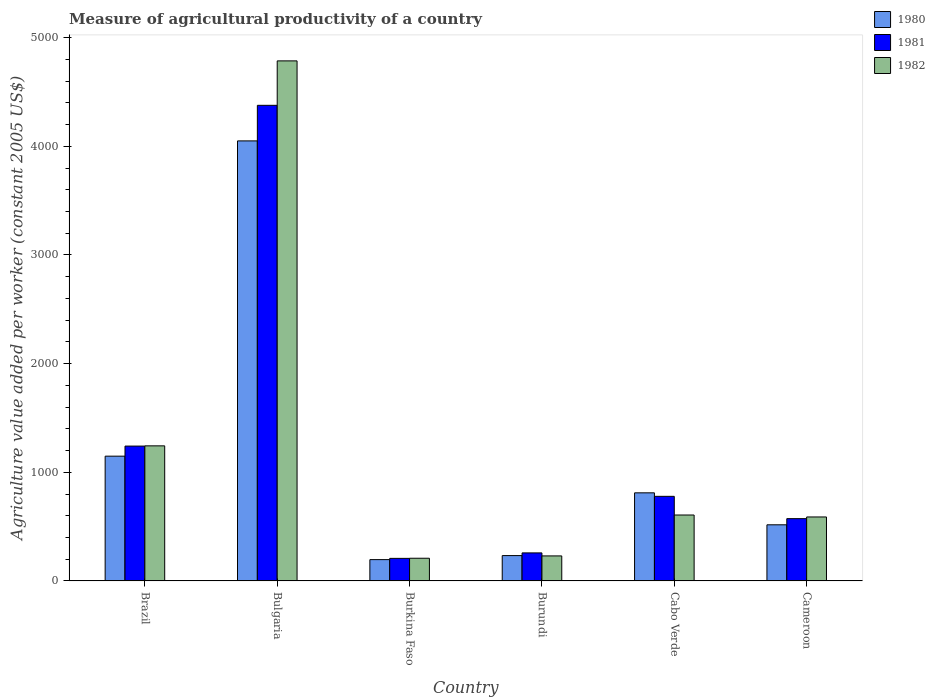How many different coloured bars are there?
Offer a very short reply. 3. How many groups of bars are there?
Provide a succinct answer. 6. Are the number of bars per tick equal to the number of legend labels?
Provide a short and direct response. Yes. Are the number of bars on each tick of the X-axis equal?
Offer a very short reply. Yes. How many bars are there on the 5th tick from the left?
Provide a short and direct response. 3. What is the label of the 1st group of bars from the left?
Ensure brevity in your answer.  Brazil. In how many cases, is the number of bars for a given country not equal to the number of legend labels?
Your answer should be compact. 0. What is the measure of agricultural productivity in 1980 in Brazil?
Offer a very short reply. 1148.46. Across all countries, what is the maximum measure of agricultural productivity in 1981?
Give a very brief answer. 4377.54. Across all countries, what is the minimum measure of agricultural productivity in 1982?
Your answer should be compact. 208.91. In which country was the measure of agricultural productivity in 1981 minimum?
Your response must be concise. Burkina Faso. What is the total measure of agricultural productivity in 1980 in the graph?
Give a very brief answer. 6955.51. What is the difference between the measure of agricultural productivity in 1980 in Bulgaria and that in Burkina Faso?
Provide a short and direct response. 3853.72. What is the difference between the measure of agricultural productivity in 1981 in Burundi and the measure of agricultural productivity in 1982 in Cabo Verde?
Make the answer very short. -348.66. What is the average measure of agricultural productivity in 1980 per country?
Ensure brevity in your answer.  1159.25. What is the difference between the measure of agricultural productivity of/in 1980 and measure of agricultural productivity of/in 1981 in Burundi?
Your response must be concise. -24.79. What is the ratio of the measure of agricultural productivity in 1980 in Bulgaria to that in Cameroon?
Provide a short and direct response. 7.84. Is the measure of agricultural productivity in 1980 in Brazil less than that in Cabo Verde?
Your answer should be compact. No. What is the difference between the highest and the second highest measure of agricultural productivity in 1980?
Provide a short and direct response. 3239.07. What is the difference between the highest and the lowest measure of agricultural productivity in 1981?
Give a very brief answer. 4169.76. Is the sum of the measure of agricultural productivity in 1980 in Brazil and Cabo Verde greater than the maximum measure of agricultural productivity in 1982 across all countries?
Ensure brevity in your answer.  No. What does the 1st bar from the left in Cameroon represents?
Your answer should be very brief. 1980. Is it the case that in every country, the sum of the measure of agricultural productivity in 1982 and measure of agricultural productivity in 1980 is greater than the measure of agricultural productivity in 1981?
Provide a succinct answer. Yes. What is the difference between two consecutive major ticks on the Y-axis?
Make the answer very short. 1000. Does the graph contain any zero values?
Your answer should be very brief. No. Where does the legend appear in the graph?
Offer a very short reply. Top right. How many legend labels are there?
Your answer should be compact. 3. How are the legend labels stacked?
Make the answer very short. Vertical. What is the title of the graph?
Ensure brevity in your answer.  Measure of agricultural productivity of a country. Does "1987" appear as one of the legend labels in the graph?
Provide a succinct answer. No. What is the label or title of the X-axis?
Make the answer very short. Country. What is the label or title of the Y-axis?
Offer a very short reply. Agriculture value added per worker (constant 2005 US$). What is the Agriculture value added per worker (constant 2005 US$) of 1980 in Brazil?
Provide a succinct answer. 1148.46. What is the Agriculture value added per worker (constant 2005 US$) in 1981 in Brazil?
Your response must be concise. 1241.2. What is the Agriculture value added per worker (constant 2005 US$) of 1982 in Brazil?
Offer a very short reply. 1243.26. What is the Agriculture value added per worker (constant 2005 US$) of 1980 in Bulgaria?
Give a very brief answer. 4049.97. What is the Agriculture value added per worker (constant 2005 US$) of 1981 in Bulgaria?
Your answer should be compact. 4377.54. What is the Agriculture value added per worker (constant 2005 US$) of 1982 in Bulgaria?
Provide a short and direct response. 4786.52. What is the Agriculture value added per worker (constant 2005 US$) of 1980 in Burkina Faso?
Make the answer very short. 196.25. What is the Agriculture value added per worker (constant 2005 US$) in 1981 in Burkina Faso?
Offer a terse response. 207.78. What is the Agriculture value added per worker (constant 2005 US$) in 1982 in Burkina Faso?
Keep it short and to the point. 208.91. What is the Agriculture value added per worker (constant 2005 US$) of 1980 in Burundi?
Offer a terse response. 233.32. What is the Agriculture value added per worker (constant 2005 US$) in 1981 in Burundi?
Ensure brevity in your answer.  258.11. What is the Agriculture value added per worker (constant 2005 US$) in 1982 in Burundi?
Make the answer very short. 230.29. What is the Agriculture value added per worker (constant 2005 US$) in 1980 in Cabo Verde?
Your response must be concise. 810.9. What is the Agriculture value added per worker (constant 2005 US$) in 1981 in Cabo Verde?
Give a very brief answer. 778.63. What is the Agriculture value added per worker (constant 2005 US$) in 1982 in Cabo Verde?
Your response must be concise. 606.77. What is the Agriculture value added per worker (constant 2005 US$) of 1980 in Cameroon?
Make the answer very short. 516.62. What is the Agriculture value added per worker (constant 2005 US$) in 1981 in Cameroon?
Keep it short and to the point. 573.32. What is the Agriculture value added per worker (constant 2005 US$) of 1982 in Cameroon?
Your answer should be compact. 588.87. Across all countries, what is the maximum Agriculture value added per worker (constant 2005 US$) in 1980?
Your answer should be compact. 4049.97. Across all countries, what is the maximum Agriculture value added per worker (constant 2005 US$) of 1981?
Give a very brief answer. 4377.54. Across all countries, what is the maximum Agriculture value added per worker (constant 2005 US$) of 1982?
Provide a short and direct response. 4786.52. Across all countries, what is the minimum Agriculture value added per worker (constant 2005 US$) of 1980?
Give a very brief answer. 196.25. Across all countries, what is the minimum Agriculture value added per worker (constant 2005 US$) in 1981?
Offer a terse response. 207.78. Across all countries, what is the minimum Agriculture value added per worker (constant 2005 US$) of 1982?
Offer a very short reply. 208.91. What is the total Agriculture value added per worker (constant 2005 US$) in 1980 in the graph?
Offer a very short reply. 6955.51. What is the total Agriculture value added per worker (constant 2005 US$) of 1981 in the graph?
Make the answer very short. 7436.59. What is the total Agriculture value added per worker (constant 2005 US$) in 1982 in the graph?
Offer a very short reply. 7664.62. What is the difference between the Agriculture value added per worker (constant 2005 US$) of 1980 in Brazil and that in Bulgaria?
Offer a very short reply. -2901.51. What is the difference between the Agriculture value added per worker (constant 2005 US$) of 1981 in Brazil and that in Bulgaria?
Offer a terse response. -3136.34. What is the difference between the Agriculture value added per worker (constant 2005 US$) in 1982 in Brazil and that in Bulgaria?
Offer a very short reply. -3543.26. What is the difference between the Agriculture value added per worker (constant 2005 US$) in 1980 in Brazil and that in Burkina Faso?
Make the answer very short. 952.21. What is the difference between the Agriculture value added per worker (constant 2005 US$) in 1981 in Brazil and that in Burkina Faso?
Provide a short and direct response. 1033.42. What is the difference between the Agriculture value added per worker (constant 2005 US$) in 1982 in Brazil and that in Burkina Faso?
Give a very brief answer. 1034.35. What is the difference between the Agriculture value added per worker (constant 2005 US$) in 1980 in Brazil and that in Burundi?
Give a very brief answer. 915.13. What is the difference between the Agriculture value added per worker (constant 2005 US$) of 1981 in Brazil and that in Burundi?
Provide a succinct answer. 983.09. What is the difference between the Agriculture value added per worker (constant 2005 US$) of 1982 in Brazil and that in Burundi?
Offer a very short reply. 1012.97. What is the difference between the Agriculture value added per worker (constant 2005 US$) in 1980 in Brazil and that in Cabo Verde?
Make the answer very short. 337.56. What is the difference between the Agriculture value added per worker (constant 2005 US$) in 1981 in Brazil and that in Cabo Verde?
Your answer should be very brief. 462.57. What is the difference between the Agriculture value added per worker (constant 2005 US$) in 1982 in Brazil and that in Cabo Verde?
Make the answer very short. 636.49. What is the difference between the Agriculture value added per worker (constant 2005 US$) in 1980 in Brazil and that in Cameroon?
Offer a terse response. 631.84. What is the difference between the Agriculture value added per worker (constant 2005 US$) in 1981 in Brazil and that in Cameroon?
Your answer should be compact. 667.88. What is the difference between the Agriculture value added per worker (constant 2005 US$) of 1982 in Brazil and that in Cameroon?
Your response must be concise. 654.39. What is the difference between the Agriculture value added per worker (constant 2005 US$) of 1980 in Bulgaria and that in Burkina Faso?
Ensure brevity in your answer.  3853.72. What is the difference between the Agriculture value added per worker (constant 2005 US$) of 1981 in Bulgaria and that in Burkina Faso?
Your answer should be very brief. 4169.76. What is the difference between the Agriculture value added per worker (constant 2005 US$) in 1982 in Bulgaria and that in Burkina Faso?
Your answer should be very brief. 4577.61. What is the difference between the Agriculture value added per worker (constant 2005 US$) in 1980 in Bulgaria and that in Burundi?
Offer a terse response. 3816.65. What is the difference between the Agriculture value added per worker (constant 2005 US$) in 1981 in Bulgaria and that in Burundi?
Provide a succinct answer. 4119.43. What is the difference between the Agriculture value added per worker (constant 2005 US$) of 1982 in Bulgaria and that in Burundi?
Make the answer very short. 4556.24. What is the difference between the Agriculture value added per worker (constant 2005 US$) in 1980 in Bulgaria and that in Cabo Verde?
Keep it short and to the point. 3239.07. What is the difference between the Agriculture value added per worker (constant 2005 US$) in 1981 in Bulgaria and that in Cabo Verde?
Keep it short and to the point. 3598.91. What is the difference between the Agriculture value added per worker (constant 2005 US$) of 1982 in Bulgaria and that in Cabo Verde?
Offer a terse response. 4179.75. What is the difference between the Agriculture value added per worker (constant 2005 US$) in 1980 in Bulgaria and that in Cameroon?
Your response must be concise. 3533.35. What is the difference between the Agriculture value added per worker (constant 2005 US$) of 1981 in Bulgaria and that in Cameroon?
Offer a terse response. 3804.22. What is the difference between the Agriculture value added per worker (constant 2005 US$) of 1982 in Bulgaria and that in Cameroon?
Provide a short and direct response. 4197.65. What is the difference between the Agriculture value added per worker (constant 2005 US$) in 1980 in Burkina Faso and that in Burundi?
Give a very brief answer. -37.08. What is the difference between the Agriculture value added per worker (constant 2005 US$) of 1981 in Burkina Faso and that in Burundi?
Provide a succinct answer. -50.33. What is the difference between the Agriculture value added per worker (constant 2005 US$) of 1982 in Burkina Faso and that in Burundi?
Your response must be concise. -21.37. What is the difference between the Agriculture value added per worker (constant 2005 US$) in 1980 in Burkina Faso and that in Cabo Verde?
Keep it short and to the point. -614.65. What is the difference between the Agriculture value added per worker (constant 2005 US$) in 1981 in Burkina Faso and that in Cabo Verde?
Your answer should be compact. -570.85. What is the difference between the Agriculture value added per worker (constant 2005 US$) of 1982 in Burkina Faso and that in Cabo Verde?
Provide a succinct answer. -397.86. What is the difference between the Agriculture value added per worker (constant 2005 US$) of 1980 in Burkina Faso and that in Cameroon?
Provide a short and direct response. -320.37. What is the difference between the Agriculture value added per worker (constant 2005 US$) in 1981 in Burkina Faso and that in Cameroon?
Keep it short and to the point. -365.54. What is the difference between the Agriculture value added per worker (constant 2005 US$) in 1982 in Burkina Faso and that in Cameroon?
Give a very brief answer. -379.96. What is the difference between the Agriculture value added per worker (constant 2005 US$) in 1980 in Burundi and that in Cabo Verde?
Your answer should be very brief. -577.57. What is the difference between the Agriculture value added per worker (constant 2005 US$) of 1981 in Burundi and that in Cabo Verde?
Your answer should be very brief. -520.52. What is the difference between the Agriculture value added per worker (constant 2005 US$) in 1982 in Burundi and that in Cabo Verde?
Provide a short and direct response. -376.49. What is the difference between the Agriculture value added per worker (constant 2005 US$) of 1980 in Burundi and that in Cameroon?
Your response must be concise. -283.29. What is the difference between the Agriculture value added per worker (constant 2005 US$) in 1981 in Burundi and that in Cameroon?
Keep it short and to the point. -315.21. What is the difference between the Agriculture value added per worker (constant 2005 US$) of 1982 in Burundi and that in Cameroon?
Offer a very short reply. -358.59. What is the difference between the Agriculture value added per worker (constant 2005 US$) in 1980 in Cabo Verde and that in Cameroon?
Keep it short and to the point. 294.28. What is the difference between the Agriculture value added per worker (constant 2005 US$) of 1981 in Cabo Verde and that in Cameroon?
Your answer should be very brief. 205.31. What is the difference between the Agriculture value added per worker (constant 2005 US$) of 1982 in Cabo Verde and that in Cameroon?
Make the answer very short. 17.9. What is the difference between the Agriculture value added per worker (constant 2005 US$) in 1980 in Brazil and the Agriculture value added per worker (constant 2005 US$) in 1981 in Bulgaria?
Your answer should be compact. -3229.09. What is the difference between the Agriculture value added per worker (constant 2005 US$) of 1980 in Brazil and the Agriculture value added per worker (constant 2005 US$) of 1982 in Bulgaria?
Ensure brevity in your answer.  -3638.07. What is the difference between the Agriculture value added per worker (constant 2005 US$) of 1981 in Brazil and the Agriculture value added per worker (constant 2005 US$) of 1982 in Bulgaria?
Provide a short and direct response. -3545.32. What is the difference between the Agriculture value added per worker (constant 2005 US$) of 1980 in Brazil and the Agriculture value added per worker (constant 2005 US$) of 1981 in Burkina Faso?
Ensure brevity in your answer.  940.67. What is the difference between the Agriculture value added per worker (constant 2005 US$) of 1980 in Brazil and the Agriculture value added per worker (constant 2005 US$) of 1982 in Burkina Faso?
Your response must be concise. 939.54. What is the difference between the Agriculture value added per worker (constant 2005 US$) of 1981 in Brazil and the Agriculture value added per worker (constant 2005 US$) of 1982 in Burkina Faso?
Your response must be concise. 1032.29. What is the difference between the Agriculture value added per worker (constant 2005 US$) in 1980 in Brazil and the Agriculture value added per worker (constant 2005 US$) in 1981 in Burundi?
Ensure brevity in your answer.  890.34. What is the difference between the Agriculture value added per worker (constant 2005 US$) of 1980 in Brazil and the Agriculture value added per worker (constant 2005 US$) of 1982 in Burundi?
Give a very brief answer. 918.17. What is the difference between the Agriculture value added per worker (constant 2005 US$) of 1981 in Brazil and the Agriculture value added per worker (constant 2005 US$) of 1982 in Burundi?
Your answer should be very brief. 1010.92. What is the difference between the Agriculture value added per worker (constant 2005 US$) of 1980 in Brazil and the Agriculture value added per worker (constant 2005 US$) of 1981 in Cabo Verde?
Make the answer very short. 369.83. What is the difference between the Agriculture value added per worker (constant 2005 US$) of 1980 in Brazil and the Agriculture value added per worker (constant 2005 US$) of 1982 in Cabo Verde?
Your answer should be compact. 541.68. What is the difference between the Agriculture value added per worker (constant 2005 US$) in 1981 in Brazil and the Agriculture value added per worker (constant 2005 US$) in 1982 in Cabo Verde?
Your answer should be very brief. 634.43. What is the difference between the Agriculture value added per worker (constant 2005 US$) in 1980 in Brazil and the Agriculture value added per worker (constant 2005 US$) in 1981 in Cameroon?
Keep it short and to the point. 575.14. What is the difference between the Agriculture value added per worker (constant 2005 US$) in 1980 in Brazil and the Agriculture value added per worker (constant 2005 US$) in 1982 in Cameroon?
Your answer should be compact. 559.58. What is the difference between the Agriculture value added per worker (constant 2005 US$) in 1981 in Brazil and the Agriculture value added per worker (constant 2005 US$) in 1982 in Cameroon?
Provide a succinct answer. 652.33. What is the difference between the Agriculture value added per worker (constant 2005 US$) of 1980 in Bulgaria and the Agriculture value added per worker (constant 2005 US$) of 1981 in Burkina Faso?
Your answer should be very brief. 3842.18. What is the difference between the Agriculture value added per worker (constant 2005 US$) in 1980 in Bulgaria and the Agriculture value added per worker (constant 2005 US$) in 1982 in Burkina Faso?
Your answer should be compact. 3841.06. What is the difference between the Agriculture value added per worker (constant 2005 US$) of 1981 in Bulgaria and the Agriculture value added per worker (constant 2005 US$) of 1982 in Burkina Faso?
Offer a terse response. 4168.63. What is the difference between the Agriculture value added per worker (constant 2005 US$) of 1980 in Bulgaria and the Agriculture value added per worker (constant 2005 US$) of 1981 in Burundi?
Keep it short and to the point. 3791.86. What is the difference between the Agriculture value added per worker (constant 2005 US$) in 1980 in Bulgaria and the Agriculture value added per worker (constant 2005 US$) in 1982 in Burundi?
Your answer should be very brief. 3819.68. What is the difference between the Agriculture value added per worker (constant 2005 US$) of 1981 in Bulgaria and the Agriculture value added per worker (constant 2005 US$) of 1982 in Burundi?
Your answer should be very brief. 4147.26. What is the difference between the Agriculture value added per worker (constant 2005 US$) in 1980 in Bulgaria and the Agriculture value added per worker (constant 2005 US$) in 1981 in Cabo Verde?
Offer a terse response. 3271.34. What is the difference between the Agriculture value added per worker (constant 2005 US$) of 1980 in Bulgaria and the Agriculture value added per worker (constant 2005 US$) of 1982 in Cabo Verde?
Your answer should be compact. 3443.2. What is the difference between the Agriculture value added per worker (constant 2005 US$) in 1981 in Bulgaria and the Agriculture value added per worker (constant 2005 US$) in 1982 in Cabo Verde?
Give a very brief answer. 3770.77. What is the difference between the Agriculture value added per worker (constant 2005 US$) of 1980 in Bulgaria and the Agriculture value added per worker (constant 2005 US$) of 1981 in Cameroon?
Provide a succinct answer. 3476.65. What is the difference between the Agriculture value added per worker (constant 2005 US$) of 1980 in Bulgaria and the Agriculture value added per worker (constant 2005 US$) of 1982 in Cameroon?
Give a very brief answer. 3461.1. What is the difference between the Agriculture value added per worker (constant 2005 US$) in 1981 in Bulgaria and the Agriculture value added per worker (constant 2005 US$) in 1982 in Cameroon?
Give a very brief answer. 3788.67. What is the difference between the Agriculture value added per worker (constant 2005 US$) in 1980 in Burkina Faso and the Agriculture value added per worker (constant 2005 US$) in 1981 in Burundi?
Make the answer very short. -61.86. What is the difference between the Agriculture value added per worker (constant 2005 US$) of 1980 in Burkina Faso and the Agriculture value added per worker (constant 2005 US$) of 1982 in Burundi?
Provide a succinct answer. -34.04. What is the difference between the Agriculture value added per worker (constant 2005 US$) of 1981 in Burkina Faso and the Agriculture value added per worker (constant 2005 US$) of 1982 in Burundi?
Your answer should be compact. -22.5. What is the difference between the Agriculture value added per worker (constant 2005 US$) of 1980 in Burkina Faso and the Agriculture value added per worker (constant 2005 US$) of 1981 in Cabo Verde?
Your response must be concise. -582.38. What is the difference between the Agriculture value added per worker (constant 2005 US$) of 1980 in Burkina Faso and the Agriculture value added per worker (constant 2005 US$) of 1982 in Cabo Verde?
Ensure brevity in your answer.  -410.52. What is the difference between the Agriculture value added per worker (constant 2005 US$) of 1981 in Burkina Faso and the Agriculture value added per worker (constant 2005 US$) of 1982 in Cabo Verde?
Provide a short and direct response. -398.99. What is the difference between the Agriculture value added per worker (constant 2005 US$) in 1980 in Burkina Faso and the Agriculture value added per worker (constant 2005 US$) in 1981 in Cameroon?
Your answer should be very brief. -377.07. What is the difference between the Agriculture value added per worker (constant 2005 US$) of 1980 in Burkina Faso and the Agriculture value added per worker (constant 2005 US$) of 1982 in Cameroon?
Provide a short and direct response. -392.63. What is the difference between the Agriculture value added per worker (constant 2005 US$) of 1981 in Burkina Faso and the Agriculture value added per worker (constant 2005 US$) of 1982 in Cameroon?
Make the answer very short. -381.09. What is the difference between the Agriculture value added per worker (constant 2005 US$) in 1980 in Burundi and the Agriculture value added per worker (constant 2005 US$) in 1981 in Cabo Verde?
Your answer should be very brief. -545.31. What is the difference between the Agriculture value added per worker (constant 2005 US$) in 1980 in Burundi and the Agriculture value added per worker (constant 2005 US$) in 1982 in Cabo Verde?
Your answer should be very brief. -373.45. What is the difference between the Agriculture value added per worker (constant 2005 US$) in 1981 in Burundi and the Agriculture value added per worker (constant 2005 US$) in 1982 in Cabo Verde?
Give a very brief answer. -348.66. What is the difference between the Agriculture value added per worker (constant 2005 US$) in 1980 in Burundi and the Agriculture value added per worker (constant 2005 US$) in 1981 in Cameroon?
Make the answer very short. -340. What is the difference between the Agriculture value added per worker (constant 2005 US$) of 1980 in Burundi and the Agriculture value added per worker (constant 2005 US$) of 1982 in Cameroon?
Your answer should be compact. -355.55. What is the difference between the Agriculture value added per worker (constant 2005 US$) of 1981 in Burundi and the Agriculture value added per worker (constant 2005 US$) of 1982 in Cameroon?
Provide a succinct answer. -330.76. What is the difference between the Agriculture value added per worker (constant 2005 US$) of 1980 in Cabo Verde and the Agriculture value added per worker (constant 2005 US$) of 1981 in Cameroon?
Provide a short and direct response. 237.58. What is the difference between the Agriculture value added per worker (constant 2005 US$) of 1980 in Cabo Verde and the Agriculture value added per worker (constant 2005 US$) of 1982 in Cameroon?
Offer a very short reply. 222.02. What is the difference between the Agriculture value added per worker (constant 2005 US$) in 1981 in Cabo Verde and the Agriculture value added per worker (constant 2005 US$) in 1982 in Cameroon?
Ensure brevity in your answer.  189.76. What is the average Agriculture value added per worker (constant 2005 US$) of 1980 per country?
Your answer should be very brief. 1159.25. What is the average Agriculture value added per worker (constant 2005 US$) of 1981 per country?
Give a very brief answer. 1239.43. What is the average Agriculture value added per worker (constant 2005 US$) of 1982 per country?
Offer a very short reply. 1277.44. What is the difference between the Agriculture value added per worker (constant 2005 US$) in 1980 and Agriculture value added per worker (constant 2005 US$) in 1981 in Brazil?
Your answer should be compact. -92.75. What is the difference between the Agriculture value added per worker (constant 2005 US$) in 1980 and Agriculture value added per worker (constant 2005 US$) in 1982 in Brazil?
Make the answer very short. -94.81. What is the difference between the Agriculture value added per worker (constant 2005 US$) in 1981 and Agriculture value added per worker (constant 2005 US$) in 1982 in Brazil?
Offer a terse response. -2.06. What is the difference between the Agriculture value added per worker (constant 2005 US$) in 1980 and Agriculture value added per worker (constant 2005 US$) in 1981 in Bulgaria?
Offer a terse response. -327.57. What is the difference between the Agriculture value added per worker (constant 2005 US$) of 1980 and Agriculture value added per worker (constant 2005 US$) of 1982 in Bulgaria?
Your answer should be compact. -736.55. What is the difference between the Agriculture value added per worker (constant 2005 US$) of 1981 and Agriculture value added per worker (constant 2005 US$) of 1982 in Bulgaria?
Offer a very short reply. -408.98. What is the difference between the Agriculture value added per worker (constant 2005 US$) of 1980 and Agriculture value added per worker (constant 2005 US$) of 1981 in Burkina Faso?
Give a very brief answer. -11.54. What is the difference between the Agriculture value added per worker (constant 2005 US$) of 1980 and Agriculture value added per worker (constant 2005 US$) of 1982 in Burkina Faso?
Offer a very short reply. -12.66. What is the difference between the Agriculture value added per worker (constant 2005 US$) in 1981 and Agriculture value added per worker (constant 2005 US$) in 1982 in Burkina Faso?
Your answer should be very brief. -1.13. What is the difference between the Agriculture value added per worker (constant 2005 US$) of 1980 and Agriculture value added per worker (constant 2005 US$) of 1981 in Burundi?
Your response must be concise. -24.79. What is the difference between the Agriculture value added per worker (constant 2005 US$) in 1980 and Agriculture value added per worker (constant 2005 US$) in 1982 in Burundi?
Your answer should be compact. 3.04. What is the difference between the Agriculture value added per worker (constant 2005 US$) of 1981 and Agriculture value added per worker (constant 2005 US$) of 1982 in Burundi?
Provide a short and direct response. 27.82. What is the difference between the Agriculture value added per worker (constant 2005 US$) of 1980 and Agriculture value added per worker (constant 2005 US$) of 1981 in Cabo Verde?
Ensure brevity in your answer.  32.27. What is the difference between the Agriculture value added per worker (constant 2005 US$) of 1980 and Agriculture value added per worker (constant 2005 US$) of 1982 in Cabo Verde?
Your answer should be compact. 204.13. What is the difference between the Agriculture value added per worker (constant 2005 US$) of 1981 and Agriculture value added per worker (constant 2005 US$) of 1982 in Cabo Verde?
Give a very brief answer. 171.86. What is the difference between the Agriculture value added per worker (constant 2005 US$) in 1980 and Agriculture value added per worker (constant 2005 US$) in 1981 in Cameroon?
Ensure brevity in your answer.  -56.7. What is the difference between the Agriculture value added per worker (constant 2005 US$) in 1980 and Agriculture value added per worker (constant 2005 US$) in 1982 in Cameroon?
Your answer should be very brief. -72.26. What is the difference between the Agriculture value added per worker (constant 2005 US$) of 1981 and Agriculture value added per worker (constant 2005 US$) of 1982 in Cameroon?
Offer a very short reply. -15.55. What is the ratio of the Agriculture value added per worker (constant 2005 US$) in 1980 in Brazil to that in Bulgaria?
Make the answer very short. 0.28. What is the ratio of the Agriculture value added per worker (constant 2005 US$) in 1981 in Brazil to that in Bulgaria?
Your answer should be compact. 0.28. What is the ratio of the Agriculture value added per worker (constant 2005 US$) of 1982 in Brazil to that in Bulgaria?
Provide a succinct answer. 0.26. What is the ratio of the Agriculture value added per worker (constant 2005 US$) in 1980 in Brazil to that in Burkina Faso?
Give a very brief answer. 5.85. What is the ratio of the Agriculture value added per worker (constant 2005 US$) of 1981 in Brazil to that in Burkina Faso?
Your answer should be very brief. 5.97. What is the ratio of the Agriculture value added per worker (constant 2005 US$) of 1982 in Brazil to that in Burkina Faso?
Keep it short and to the point. 5.95. What is the ratio of the Agriculture value added per worker (constant 2005 US$) in 1980 in Brazil to that in Burundi?
Make the answer very short. 4.92. What is the ratio of the Agriculture value added per worker (constant 2005 US$) in 1981 in Brazil to that in Burundi?
Offer a very short reply. 4.81. What is the ratio of the Agriculture value added per worker (constant 2005 US$) of 1982 in Brazil to that in Burundi?
Offer a very short reply. 5.4. What is the ratio of the Agriculture value added per worker (constant 2005 US$) of 1980 in Brazil to that in Cabo Verde?
Offer a very short reply. 1.42. What is the ratio of the Agriculture value added per worker (constant 2005 US$) in 1981 in Brazil to that in Cabo Verde?
Offer a very short reply. 1.59. What is the ratio of the Agriculture value added per worker (constant 2005 US$) of 1982 in Brazil to that in Cabo Verde?
Offer a very short reply. 2.05. What is the ratio of the Agriculture value added per worker (constant 2005 US$) of 1980 in Brazil to that in Cameroon?
Provide a short and direct response. 2.22. What is the ratio of the Agriculture value added per worker (constant 2005 US$) of 1981 in Brazil to that in Cameroon?
Make the answer very short. 2.16. What is the ratio of the Agriculture value added per worker (constant 2005 US$) of 1982 in Brazil to that in Cameroon?
Make the answer very short. 2.11. What is the ratio of the Agriculture value added per worker (constant 2005 US$) in 1980 in Bulgaria to that in Burkina Faso?
Your response must be concise. 20.64. What is the ratio of the Agriculture value added per worker (constant 2005 US$) of 1981 in Bulgaria to that in Burkina Faso?
Provide a succinct answer. 21.07. What is the ratio of the Agriculture value added per worker (constant 2005 US$) in 1982 in Bulgaria to that in Burkina Faso?
Make the answer very short. 22.91. What is the ratio of the Agriculture value added per worker (constant 2005 US$) of 1980 in Bulgaria to that in Burundi?
Your answer should be compact. 17.36. What is the ratio of the Agriculture value added per worker (constant 2005 US$) in 1981 in Bulgaria to that in Burundi?
Your answer should be very brief. 16.96. What is the ratio of the Agriculture value added per worker (constant 2005 US$) of 1982 in Bulgaria to that in Burundi?
Your answer should be compact. 20.79. What is the ratio of the Agriculture value added per worker (constant 2005 US$) in 1980 in Bulgaria to that in Cabo Verde?
Keep it short and to the point. 4.99. What is the ratio of the Agriculture value added per worker (constant 2005 US$) of 1981 in Bulgaria to that in Cabo Verde?
Provide a succinct answer. 5.62. What is the ratio of the Agriculture value added per worker (constant 2005 US$) of 1982 in Bulgaria to that in Cabo Verde?
Your answer should be very brief. 7.89. What is the ratio of the Agriculture value added per worker (constant 2005 US$) of 1980 in Bulgaria to that in Cameroon?
Provide a short and direct response. 7.84. What is the ratio of the Agriculture value added per worker (constant 2005 US$) in 1981 in Bulgaria to that in Cameroon?
Make the answer very short. 7.64. What is the ratio of the Agriculture value added per worker (constant 2005 US$) of 1982 in Bulgaria to that in Cameroon?
Your answer should be compact. 8.13. What is the ratio of the Agriculture value added per worker (constant 2005 US$) of 1980 in Burkina Faso to that in Burundi?
Keep it short and to the point. 0.84. What is the ratio of the Agriculture value added per worker (constant 2005 US$) of 1981 in Burkina Faso to that in Burundi?
Make the answer very short. 0.81. What is the ratio of the Agriculture value added per worker (constant 2005 US$) of 1982 in Burkina Faso to that in Burundi?
Provide a short and direct response. 0.91. What is the ratio of the Agriculture value added per worker (constant 2005 US$) in 1980 in Burkina Faso to that in Cabo Verde?
Your response must be concise. 0.24. What is the ratio of the Agriculture value added per worker (constant 2005 US$) in 1981 in Burkina Faso to that in Cabo Verde?
Keep it short and to the point. 0.27. What is the ratio of the Agriculture value added per worker (constant 2005 US$) in 1982 in Burkina Faso to that in Cabo Verde?
Your answer should be very brief. 0.34. What is the ratio of the Agriculture value added per worker (constant 2005 US$) in 1980 in Burkina Faso to that in Cameroon?
Ensure brevity in your answer.  0.38. What is the ratio of the Agriculture value added per worker (constant 2005 US$) in 1981 in Burkina Faso to that in Cameroon?
Give a very brief answer. 0.36. What is the ratio of the Agriculture value added per worker (constant 2005 US$) of 1982 in Burkina Faso to that in Cameroon?
Your response must be concise. 0.35. What is the ratio of the Agriculture value added per worker (constant 2005 US$) of 1980 in Burundi to that in Cabo Verde?
Your answer should be compact. 0.29. What is the ratio of the Agriculture value added per worker (constant 2005 US$) in 1981 in Burundi to that in Cabo Verde?
Give a very brief answer. 0.33. What is the ratio of the Agriculture value added per worker (constant 2005 US$) of 1982 in Burundi to that in Cabo Verde?
Your response must be concise. 0.38. What is the ratio of the Agriculture value added per worker (constant 2005 US$) of 1980 in Burundi to that in Cameroon?
Give a very brief answer. 0.45. What is the ratio of the Agriculture value added per worker (constant 2005 US$) of 1981 in Burundi to that in Cameroon?
Make the answer very short. 0.45. What is the ratio of the Agriculture value added per worker (constant 2005 US$) in 1982 in Burundi to that in Cameroon?
Offer a terse response. 0.39. What is the ratio of the Agriculture value added per worker (constant 2005 US$) in 1980 in Cabo Verde to that in Cameroon?
Offer a terse response. 1.57. What is the ratio of the Agriculture value added per worker (constant 2005 US$) in 1981 in Cabo Verde to that in Cameroon?
Make the answer very short. 1.36. What is the ratio of the Agriculture value added per worker (constant 2005 US$) in 1982 in Cabo Verde to that in Cameroon?
Your answer should be very brief. 1.03. What is the difference between the highest and the second highest Agriculture value added per worker (constant 2005 US$) of 1980?
Your answer should be compact. 2901.51. What is the difference between the highest and the second highest Agriculture value added per worker (constant 2005 US$) in 1981?
Provide a short and direct response. 3136.34. What is the difference between the highest and the second highest Agriculture value added per worker (constant 2005 US$) in 1982?
Provide a short and direct response. 3543.26. What is the difference between the highest and the lowest Agriculture value added per worker (constant 2005 US$) in 1980?
Your answer should be very brief. 3853.72. What is the difference between the highest and the lowest Agriculture value added per worker (constant 2005 US$) of 1981?
Provide a short and direct response. 4169.76. What is the difference between the highest and the lowest Agriculture value added per worker (constant 2005 US$) of 1982?
Your response must be concise. 4577.61. 